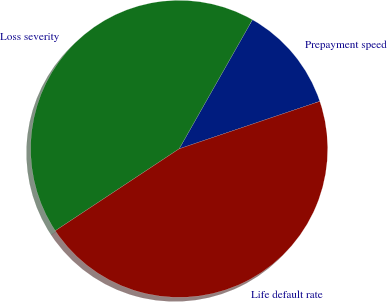<chart> <loc_0><loc_0><loc_500><loc_500><pie_chart><fcel>Prepayment speed<fcel>Loss severity<fcel>Life default rate<nl><fcel>11.6%<fcel>42.52%<fcel>45.88%<nl></chart> 